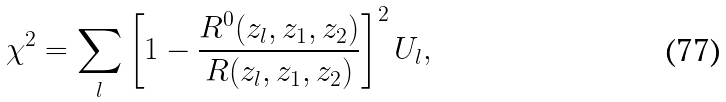Convert formula to latex. <formula><loc_0><loc_0><loc_500><loc_500>\chi ^ { 2 } = \sum _ { l } \left [ 1 - \frac { R ^ { 0 } ( z _ { l } , z _ { 1 } , z _ { 2 } ) } { R ( z _ { l } , z _ { 1 } , z _ { 2 } ) } \right ] ^ { 2 } U _ { l } ,</formula> 